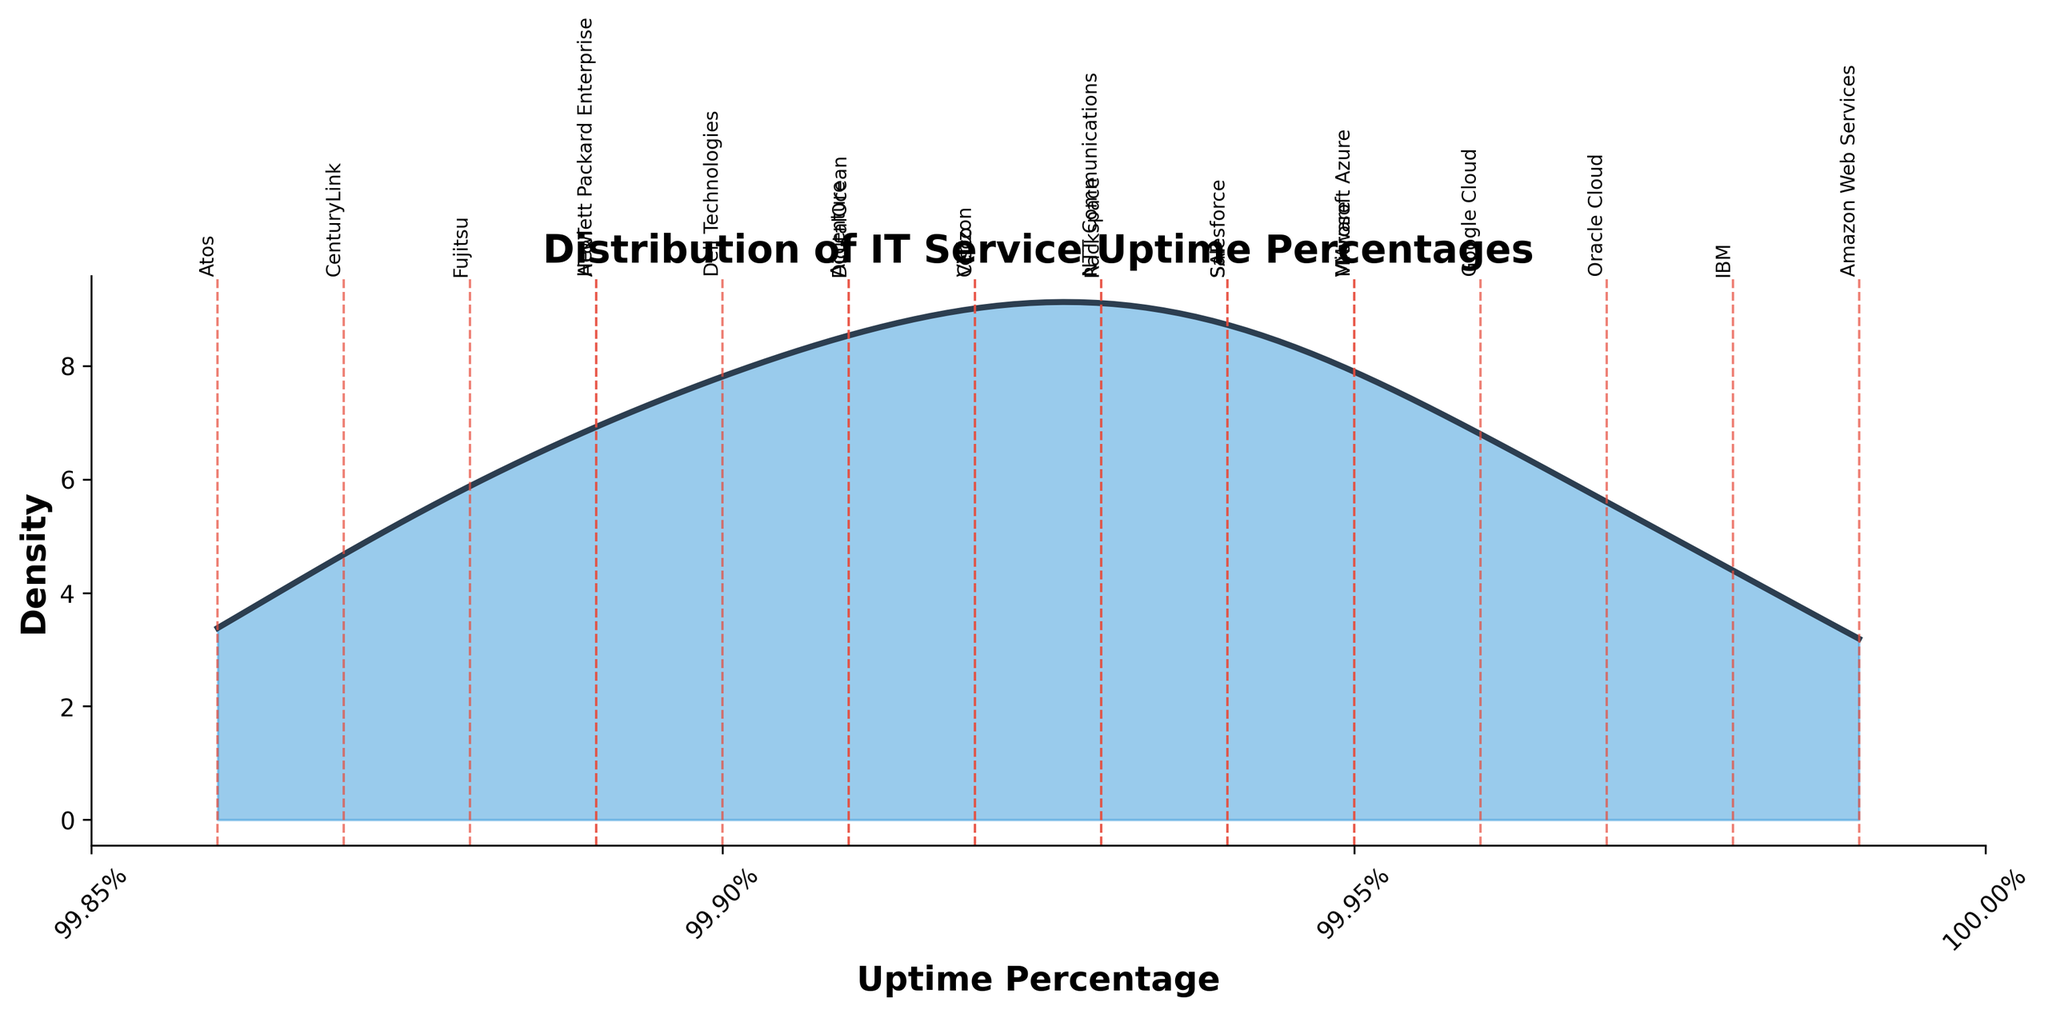What's the title of the plot? The title is displayed at the top of the plot in a larger and bolder font than other text elements.
Answer: Distribution of IT Service Uptime Percentages How many providers have an uptime percentage marked with a vertical line on the plot? Each vertical red dashed line corresponds to a provider, so count the number of those lines.
Answer: 20 Which provider has the highest uptime percentage? Look for the vertical line that extends the furthest to the right on the X-axis. The provider name is labeled near the top of this line.
Answer: Amazon Web Services What is the range of uptime percentages shown on the X-axis? Check the minimum and maximum values labeled on the X-axis.
Answer: 99.85% to 100% Which provider has the lowest uptime percentage? Look for the vertical line that extends the furthest to the left on the X-axis. The provider name is labeled near the top of this line.
Answer: Atos Between Google Cloud and Microsoft Azure, which provider has a higher uptime percentage? Identify the vertical lines corresponding to Google Cloud and Microsoft Azure, and compare their positions on the X-axis.
Answer: Google Cloud How does the density of uptime percentages change around 99.95%? Observe the height of the density curve near 99.95% on the X-axis.
Answer: The density increases and reaches a peak around this area What is the approximate maximum density value on the plot? Look for the highest point on the density curve and check the corresponding value on the Y-axis.
Answer: Approximately 0.9 Is there more density on the left or the right side of the peak around 99.95%? Compare the area under the curve to the left and right of the peak around 99.95%.
Answer: Left What does it mean when there is a vertical red dashed line at 99.93% with the label 'Rackspace'? This indicates that Rackspace has an uptime percentage of 99.93%.
Answer: Rackspace's uptime percentage is 99.93% 